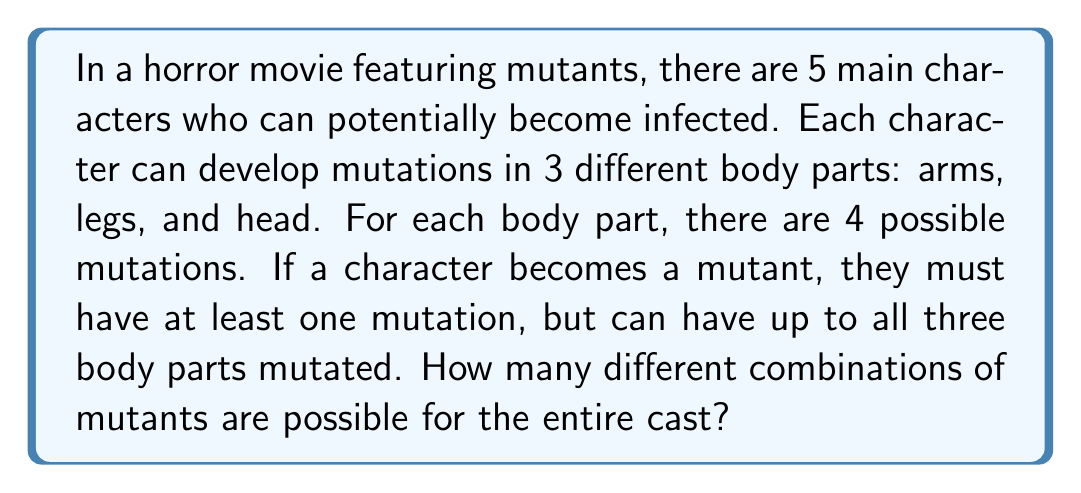What is the answer to this math problem? Let's break this down step-by-step:

1) First, let's consider the possible mutations for a single character:
   - For each body part, there are 4 possible mutations plus the option of no mutation.
   - So for each body part, there are 5 possibilities (4 mutations + 1 no mutation).

2) The total number of possibilities for one character is:
   $5 \times 5 \times 5 = 125$

3) However, we need to subtract the case where a character has no mutations at all:
   $125 - 1 = 124$

4) Now, for the entire cast of 5 characters, each character has 124 possible mutant states plus 1 non-mutant state.
   So each character has 125 possible states.

5) To find the total number of combinations for all 5 characters, we multiply:
   $125 \times 125 \times 125 \times 125 \times 125 = 125^5$

6) We can calculate this:
   $125^5 = 3,052,503,125$

Therefore, there are 3,052,503,125 possible combinations of mutants for the entire cast.
Answer: $3,052,503,125$ 